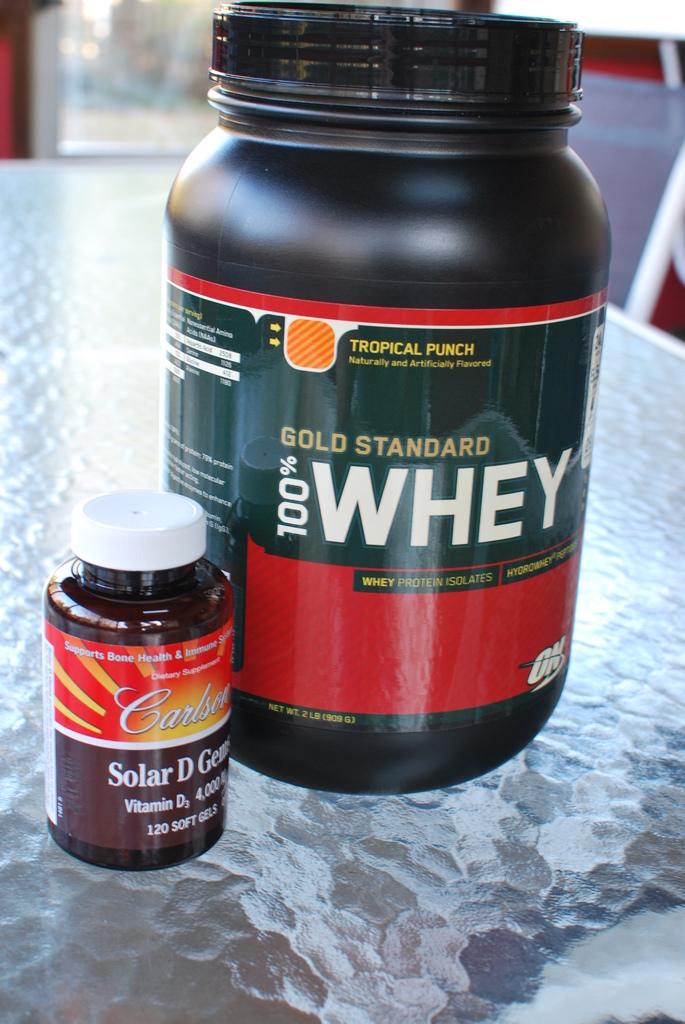What percent whey is the product?
Make the answer very short. 100. What flavor is the whey?
Make the answer very short. Tropical punch. 